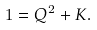Convert formula to latex. <formula><loc_0><loc_0><loc_500><loc_500>1 = Q ^ { 2 } + K .</formula> 